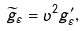<formula> <loc_0><loc_0><loc_500><loc_500>\widetilde { g } _ { \varepsilon } = \upsilon ^ { 2 } g _ { \varepsilon } ^ { \prime } ,</formula> 